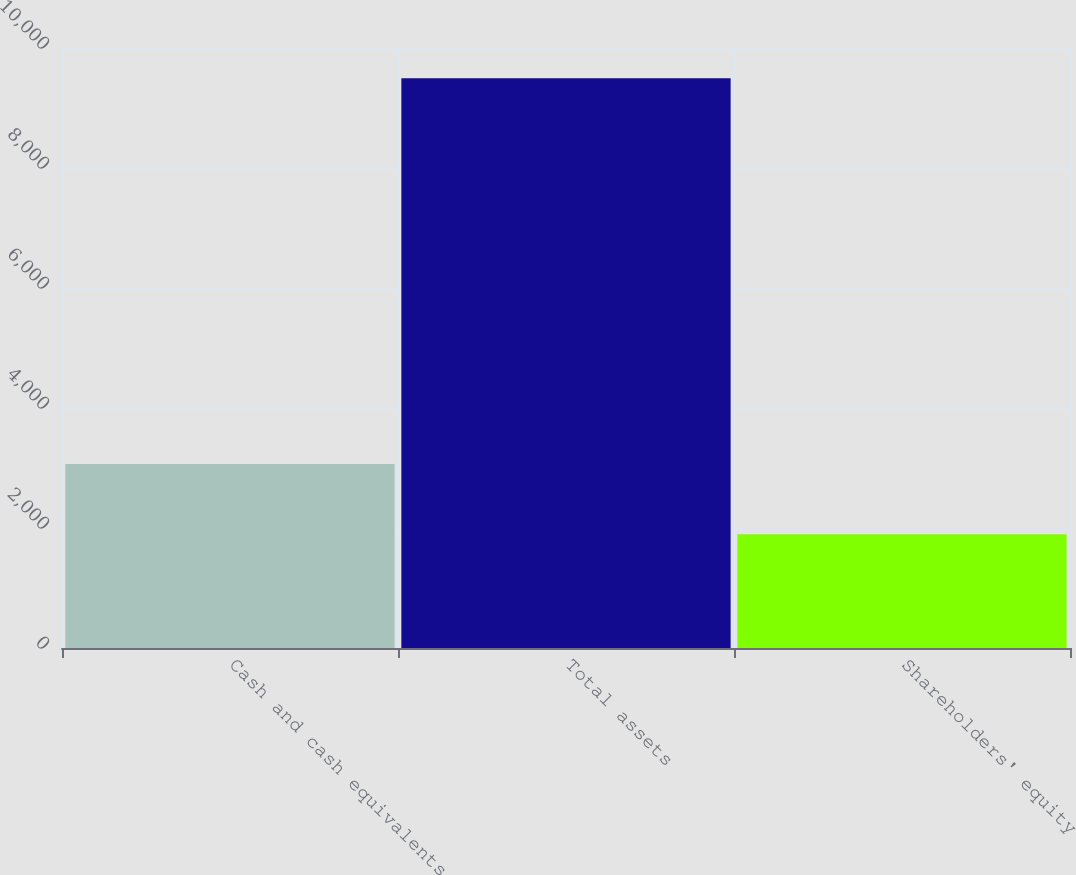<chart> <loc_0><loc_0><loc_500><loc_500><bar_chart><fcel>Cash and cash equivalents<fcel>Total assets<fcel>Shareholders' equity<nl><fcel>3067<fcel>9497<fcel>1894<nl></chart> 